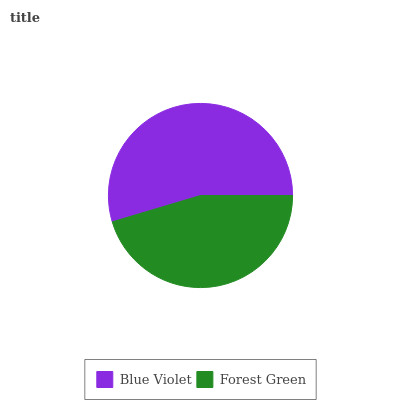Is Forest Green the minimum?
Answer yes or no. Yes. Is Blue Violet the maximum?
Answer yes or no. Yes. Is Forest Green the maximum?
Answer yes or no. No. Is Blue Violet greater than Forest Green?
Answer yes or no. Yes. Is Forest Green less than Blue Violet?
Answer yes or no. Yes. Is Forest Green greater than Blue Violet?
Answer yes or no. No. Is Blue Violet less than Forest Green?
Answer yes or no. No. Is Blue Violet the high median?
Answer yes or no. Yes. Is Forest Green the low median?
Answer yes or no. Yes. Is Forest Green the high median?
Answer yes or no. No. Is Blue Violet the low median?
Answer yes or no. No. 